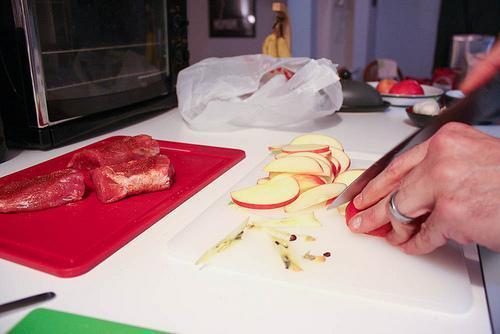How many pieces of meat are there?
Give a very brief answer. 3. How many red cutting boards are in the image?
Give a very brief answer. 1. 